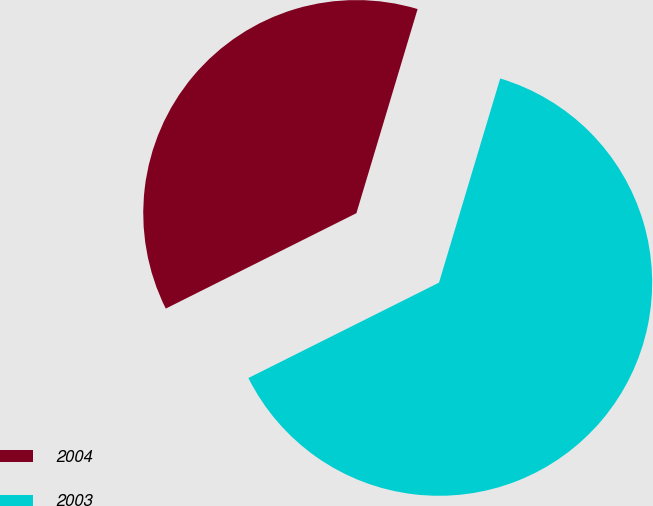Convert chart. <chart><loc_0><loc_0><loc_500><loc_500><pie_chart><fcel>2004<fcel>2003<nl><fcel>37.02%<fcel>62.98%<nl></chart> 